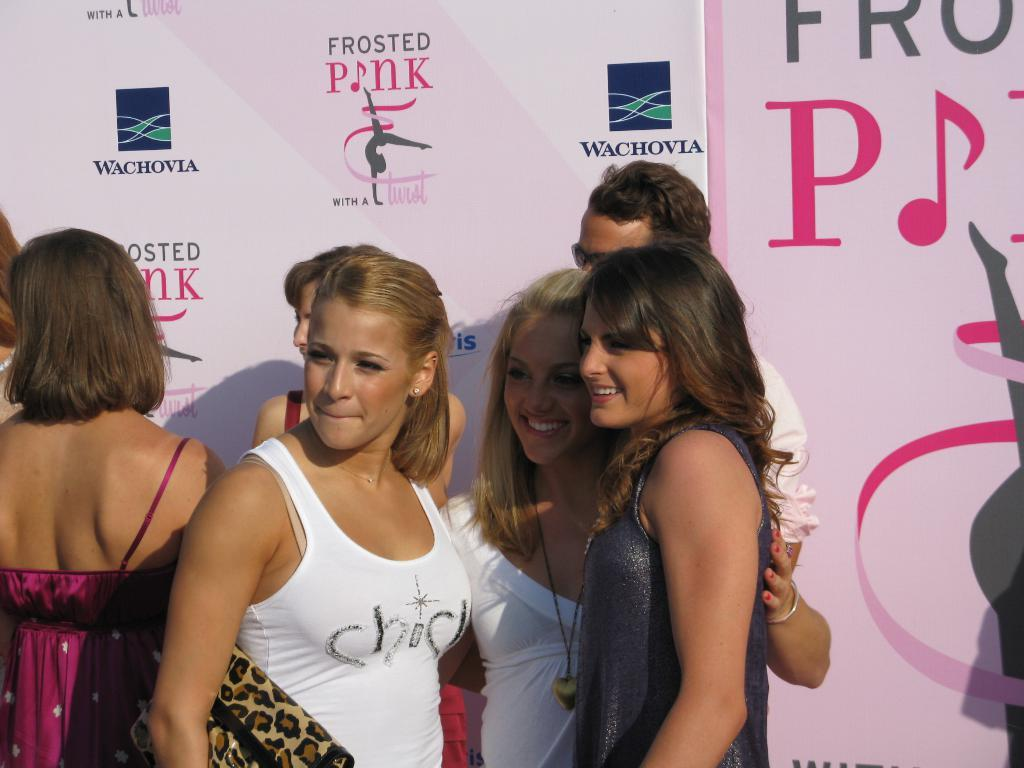What are the people in the image wearing? The people in the image are wearing different color dresses. What can be seen in the background of the image? There is a pink color board in the background of the image. What is written on the pink color board? Something is written on the pink color board, but the specific text is not mentioned in the facts. Are there any firemen present in the image? There is no mention of firemen in the image, so we cannot confirm their presence. What type of riddle is written on the pink color board? There is no mention of a riddle being written on the pink color board, so we cannot answer this question. 